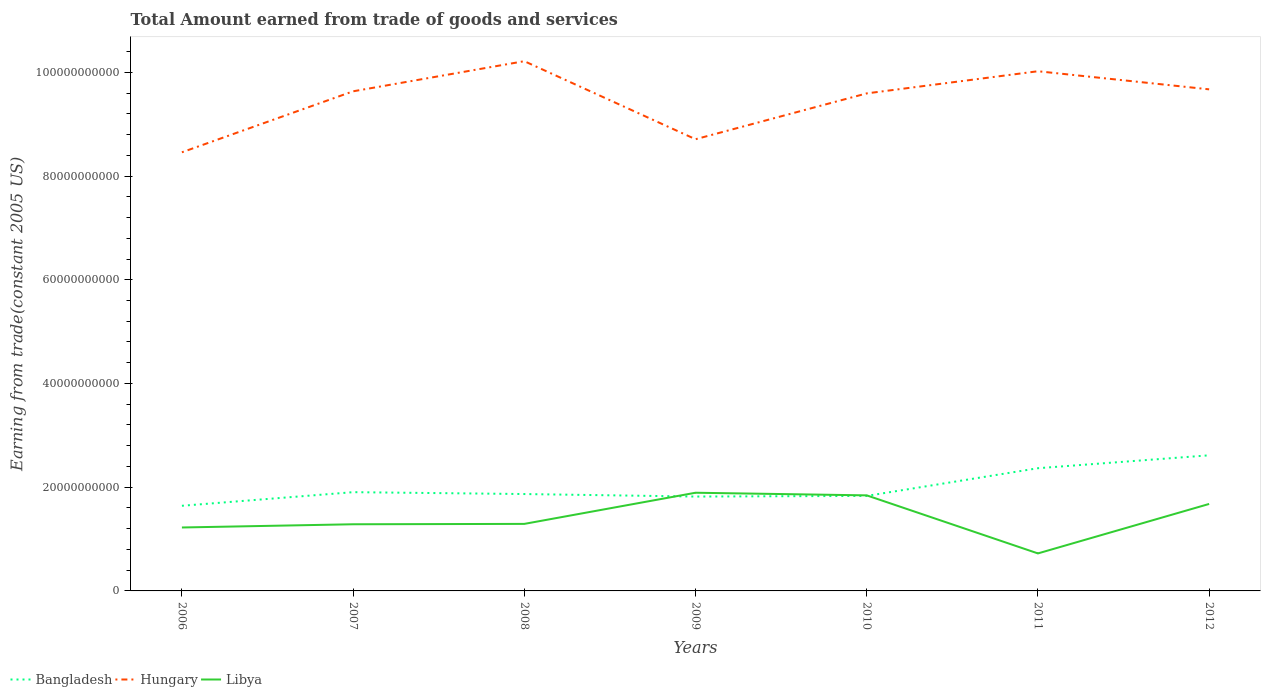Across all years, what is the maximum total amount earned by trading goods and services in Hungary?
Offer a terse response. 8.46e+1. In which year was the total amount earned by trading goods and services in Bangladesh maximum?
Ensure brevity in your answer.  2006. What is the total total amount earned by trading goods and services in Hungary in the graph?
Provide a short and direct response. -2.52e+09. What is the difference between the highest and the second highest total amount earned by trading goods and services in Hungary?
Provide a succinct answer. 1.76e+1. What is the difference between the highest and the lowest total amount earned by trading goods and services in Hungary?
Ensure brevity in your answer.  5. Is the total amount earned by trading goods and services in Hungary strictly greater than the total amount earned by trading goods and services in Libya over the years?
Your answer should be compact. No. How many years are there in the graph?
Provide a succinct answer. 7. Are the values on the major ticks of Y-axis written in scientific E-notation?
Ensure brevity in your answer.  No. Does the graph contain any zero values?
Offer a terse response. No. Where does the legend appear in the graph?
Your answer should be very brief. Bottom left. How many legend labels are there?
Your response must be concise. 3. How are the legend labels stacked?
Give a very brief answer. Horizontal. What is the title of the graph?
Your response must be concise. Total Amount earned from trade of goods and services. Does "Malawi" appear as one of the legend labels in the graph?
Offer a very short reply. No. What is the label or title of the Y-axis?
Offer a terse response. Earning from trade(constant 2005 US). What is the Earning from trade(constant 2005 US) in Bangladesh in 2006?
Give a very brief answer. 1.64e+1. What is the Earning from trade(constant 2005 US) of Hungary in 2006?
Your answer should be compact. 8.46e+1. What is the Earning from trade(constant 2005 US) in Libya in 2006?
Offer a terse response. 1.22e+1. What is the Earning from trade(constant 2005 US) in Bangladesh in 2007?
Offer a very short reply. 1.90e+1. What is the Earning from trade(constant 2005 US) in Hungary in 2007?
Ensure brevity in your answer.  9.63e+1. What is the Earning from trade(constant 2005 US) of Libya in 2007?
Give a very brief answer. 1.29e+1. What is the Earning from trade(constant 2005 US) in Bangladesh in 2008?
Offer a terse response. 1.87e+1. What is the Earning from trade(constant 2005 US) in Hungary in 2008?
Keep it short and to the point. 1.02e+11. What is the Earning from trade(constant 2005 US) of Libya in 2008?
Your answer should be compact. 1.29e+1. What is the Earning from trade(constant 2005 US) of Bangladesh in 2009?
Provide a succinct answer. 1.82e+1. What is the Earning from trade(constant 2005 US) in Hungary in 2009?
Your response must be concise. 8.71e+1. What is the Earning from trade(constant 2005 US) of Libya in 2009?
Give a very brief answer. 1.89e+1. What is the Earning from trade(constant 2005 US) in Bangladesh in 2010?
Offer a terse response. 1.83e+1. What is the Earning from trade(constant 2005 US) in Hungary in 2010?
Ensure brevity in your answer.  9.59e+1. What is the Earning from trade(constant 2005 US) in Libya in 2010?
Your answer should be very brief. 1.84e+1. What is the Earning from trade(constant 2005 US) in Bangladesh in 2011?
Keep it short and to the point. 2.37e+1. What is the Earning from trade(constant 2005 US) of Hungary in 2011?
Your response must be concise. 1.00e+11. What is the Earning from trade(constant 2005 US) of Libya in 2011?
Provide a succinct answer. 7.23e+09. What is the Earning from trade(constant 2005 US) in Bangladesh in 2012?
Ensure brevity in your answer.  2.61e+1. What is the Earning from trade(constant 2005 US) in Hungary in 2012?
Give a very brief answer. 9.67e+1. What is the Earning from trade(constant 2005 US) of Libya in 2012?
Offer a terse response. 1.68e+1. Across all years, what is the maximum Earning from trade(constant 2005 US) of Bangladesh?
Keep it short and to the point. 2.61e+1. Across all years, what is the maximum Earning from trade(constant 2005 US) of Hungary?
Offer a very short reply. 1.02e+11. Across all years, what is the maximum Earning from trade(constant 2005 US) in Libya?
Offer a terse response. 1.89e+1. Across all years, what is the minimum Earning from trade(constant 2005 US) in Bangladesh?
Make the answer very short. 1.64e+1. Across all years, what is the minimum Earning from trade(constant 2005 US) in Hungary?
Provide a short and direct response. 8.46e+1. Across all years, what is the minimum Earning from trade(constant 2005 US) of Libya?
Offer a very short reply. 7.23e+09. What is the total Earning from trade(constant 2005 US) of Bangladesh in the graph?
Ensure brevity in your answer.  1.40e+11. What is the total Earning from trade(constant 2005 US) of Hungary in the graph?
Make the answer very short. 6.63e+11. What is the total Earning from trade(constant 2005 US) of Libya in the graph?
Ensure brevity in your answer.  9.94e+1. What is the difference between the Earning from trade(constant 2005 US) in Bangladesh in 2006 and that in 2007?
Offer a terse response. -2.62e+09. What is the difference between the Earning from trade(constant 2005 US) in Hungary in 2006 and that in 2007?
Your answer should be compact. -1.18e+1. What is the difference between the Earning from trade(constant 2005 US) of Libya in 2006 and that in 2007?
Keep it short and to the point. -6.19e+08. What is the difference between the Earning from trade(constant 2005 US) in Bangladesh in 2006 and that in 2008?
Give a very brief answer. -2.26e+09. What is the difference between the Earning from trade(constant 2005 US) of Hungary in 2006 and that in 2008?
Make the answer very short. -1.76e+1. What is the difference between the Earning from trade(constant 2005 US) of Libya in 2006 and that in 2008?
Keep it short and to the point. -6.92e+08. What is the difference between the Earning from trade(constant 2005 US) of Bangladesh in 2006 and that in 2009?
Offer a very short reply. -1.78e+09. What is the difference between the Earning from trade(constant 2005 US) of Hungary in 2006 and that in 2009?
Provide a succinct answer. -2.52e+09. What is the difference between the Earning from trade(constant 2005 US) of Libya in 2006 and that in 2009?
Your answer should be very brief. -6.70e+09. What is the difference between the Earning from trade(constant 2005 US) in Bangladesh in 2006 and that in 2010?
Make the answer very short. -1.90e+09. What is the difference between the Earning from trade(constant 2005 US) of Hungary in 2006 and that in 2010?
Offer a very short reply. -1.14e+1. What is the difference between the Earning from trade(constant 2005 US) in Libya in 2006 and that in 2010?
Offer a terse response. -6.19e+09. What is the difference between the Earning from trade(constant 2005 US) in Bangladesh in 2006 and that in 2011?
Your answer should be very brief. -7.24e+09. What is the difference between the Earning from trade(constant 2005 US) of Hungary in 2006 and that in 2011?
Provide a short and direct response. -1.56e+1. What is the difference between the Earning from trade(constant 2005 US) in Libya in 2006 and that in 2011?
Your response must be concise. 5.00e+09. What is the difference between the Earning from trade(constant 2005 US) of Bangladesh in 2006 and that in 2012?
Ensure brevity in your answer.  -9.73e+09. What is the difference between the Earning from trade(constant 2005 US) in Hungary in 2006 and that in 2012?
Your answer should be compact. -1.21e+1. What is the difference between the Earning from trade(constant 2005 US) in Libya in 2006 and that in 2012?
Provide a succinct answer. -4.54e+09. What is the difference between the Earning from trade(constant 2005 US) in Bangladesh in 2007 and that in 2008?
Your answer should be very brief. 3.62e+08. What is the difference between the Earning from trade(constant 2005 US) in Hungary in 2007 and that in 2008?
Give a very brief answer. -5.81e+09. What is the difference between the Earning from trade(constant 2005 US) in Libya in 2007 and that in 2008?
Your response must be concise. -7.31e+07. What is the difference between the Earning from trade(constant 2005 US) in Bangladesh in 2007 and that in 2009?
Make the answer very short. 8.48e+08. What is the difference between the Earning from trade(constant 2005 US) of Hungary in 2007 and that in 2009?
Make the answer very short. 9.24e+09. What is the difference between the Earning from trade(constant 2005 US) in Libya in 2007 and that in 2009?
Offer a very short reply. -6.08e+09. What is the difference between the Earning from trade(constant 2005 US) of Bangladesh in 2007 and that in 2010?
Keep it short and to the point. 7.23e+08. What is the difference between the Earning from trade(constant 2005 US) in Hungary in 2007 and that in 2010?
Make the answer very short. 4.03e+08. What is the difference between the Earning from trade(constant 2005 US) of Libya in 2007 and that in 2010?
Offer a very short reply. -5.58e+09. What is the difference between the Earning from trade(constant 2005 US) in Bangladesh in 2007 and that in 2011?
Your answer should be compact. -4.62e+09. What is the difference between the Earning from trade(constant 2005 US) of Hungary in 2007 and that in 2011?
Give a very brief answer. -3.87e+09. What is the difference between the Earning from trade(constant 2005 US) of Libya in 2007 and that in 2011?
Make the answer very short. 5.62e+09. What is the difference between the Earning from trade(constant 2005 US) of Bangladesh in 2007 and that in 2012?
Give a very brief answer. -7.11e+09. What is the difference between the Earning from trade(constant 2005 US) of Hungary in 2007 and that in 2012?
Offer a very short reply. -3.78e+08. What is the difference between the Earning from trade(constant 2005 US) of Libya in 2007 and that in 2012?
Ensure brevity in your answer.  -3.92e+09. What is the difference between the Earning from trade(constant 2005 US) of Bangladesh in 2008 and that in 2009?
Offer a terse response. 4.86e+08. What is the difference between the Earning from trade(constant 2005 US) of Hungary in 2008 and that in 2009?
Make the answer very short. 1.50e+1. What is the difference between the Earning from trade(constant 2005 US) of Libya in 2008 and that in 2009?
Keep it short and to the point. -6.01e+09. What is the difference between the Earning from trade(constant 2005 US) of Bangladesh in 2008 and that in 2010?
Make the answer very short. 3.61e+08. What is the difference between the Earning from trade(constant 2005 US) in Hungary in 2008 and that in 2010?
Your answer should be compact. 6.21e+09. What is the difference between the Earning from trade(constant 2005 US) in Libya in 2008 and that in 2010?
Ensure brevity in your answer.  -5.50e+09. What is the difference between the Earning from trade(constant 2005 US) of Bangladesh in 2008 and that in 2011?
Offer a very short reply. -4.98e+09. What is the difference between the Earning from trade(constant 2005 US) in Hungary in 2008 and that in 2011?
Offer a terse response. 1.94e+09. What is the difference between the Earning from trade(constant 2005 US) of Libya in 2008 and that in 2011?
Keep it short and to the point. 5.69e+09. What is the difference between the Earning from trade(constant 2005 US) in Bangladesh in 2008 and that in 2012?
Ensure brevity in your answer.  -7.47e+09. What is the difference between the Earning from trade(constant 2005 US) of Hungary in 2008 and that in 2012?
Your answer should be very brief. 5.43e+09. What is the difference between the Earning from trade(constant 2005 US) of Libya in 2008 and that in 2012?
Offer a terse response. -3.85e+09. What is the difference between the Earning from trade(constant 2005 US) of Bangladesh in 2009 and that in 2010?
Your response must be concise. -1.25e+08. What is the difference between the Earning from trade(constant 2005 US) of Hungary in 2009 and that in 2010?
Offer a terse response. -8.84e+09. What is the difference between the Earning from trade(constant 2005 US) in Libya in 2009 and that in 2010?
Give a very brief answer. 5.07e+08. What is the difference between the Earning from trade(constant 2005 US) in Bangladesh in 2009 and that in 2011?
Keep it short and to the point. -5.47e+09. What is the difference between the Earning from trade(constant 2005 US) in Hungary in 2009 and that in 2011?
Ensure brevity in your answer.  -1.31e+1. What is the difference between the Earning from trade(constant 2005 US) of Libya in 2009 and that in 2011?
Your answer should be very brief. 1.17e+1. What is the difference between the Earning from trade(constant 2005 US) in Bangladesh in 2009 and that in 2012?
Your answer should be very brief. -7.95e+09. What is the difference between the Earning from trade(constant 2005 US) in Hungary in 2009 and that in 2012?
Provide a short and direct response. -9.62e+09. What is the difference between the Earning from trade(constant 2005 US) in Libya in 2009 and that in 2012?
Keep it short and to the point. 2.16e+09. What is the difference between the Earning from trade(constant 2005 US) in Bangladesh in 2010 and that in 2011?
Your answer should be very brief. -5.34e+09. What is the difference between the Earning from trade(constant 2005 US) of Hungary in 2010 and that in 2011?
Ensure brevity in your answer.  -4.27e+09. What is the difference between the Earning from trade(constant 2005 US) in Libya in 2010 and that in 2011?
Your answer should be very brief. 1.12e+1. What is the difference between the Earning from trade(constant 2005 US) in Bangladesh in 2010 and that in 2012?
Your answer should be very brief. -7.83e+09. What is the difference between the Earning from trade(constant 2005 US) of Hungary in 2010 and that in 2012?
Make the answer very short. -7.81e+08. What is the difference between the Earning from trade(constant 2005 US) of Libya in 2010 and that in 2012?
Give a very brief answer. 1.66e+09. What is the difference between the Earning from trade(constant 2005 US) in Bangladesh in 2011 and that in 2012?
Your response must be concise. -2.49e+09. What is the difference between the Earning from trade(constant 2005 US) of Hungary in 2011 and that in 2012?
Provide a short and direct response. 3.49e+09. What is the difference between the Earning from trade(constant 2005 US) of Libya in 2011 and that in 2012?
Your answer should be compact. -9.54e+09. What is the difference between the Earning from trade(constant 2005 US) of Bangladesh in 2006 and the Earning from trade(constant 2005 US) of Hungary in 2007?
Your response must be concise. -7.99e+1. What is the difference between the Earning from trade(constant 2005 US) of Bangladesh in 2006 and the Earning from trade(constant 2005 US) of Libya in 2007?
Your answer should be very brief. 3.57e+09. What is the difference between the Earning from trade(constant 2005 US) in Hungary in 2006 and the Earning from trade(constant 2005 US) in Libya in 2007?
Offer a terse response. 7.17e+1. What is the difference between the Earning from trade(constant 2005 US) in Bangladesh in 2006 and the Earning from trade(constant 2005 US) in Hungary in 2008?
Your response must be concise. -8.57e+1. What is the difference between the Earning from trade(constant 2005 US) in Bangladesh in 2006 and the Earning from trade(constant 2005 US) in Libya in 2008?
Offer a very short reply. 3.49e+09. What is the difference between the Earning from trade(constant 2005 US) of Hungary in 2006 and the Earning from trade(constant 2005 US) of Libya in 2008?
Your answer should be compact. 7.17e+1. What is the difference between the Earning from trade(constant 2005 US) in Bangladesh in 2006 and the Earning from trade(constant 2005 US) in Hungary in 2009?
Offer a terse response. -7.07e+1. What is the difference between the Earning from trade(constant 2005 US) of Bangladesh in 2006 and the Earning from trade(constant 2005 US) of Libya in 2009?
Make the answer very short. -2.52e+09. What is the difference between the Earning from trade(constant 2005 US) of Hungary in 2006 and the Earning from trade(constant 2005 US) of Libya in 2009?
Your answer should be compact. 6.56e+1. What is the difference between the Earning from trade(constant 2005 US) of Bangladesh in 2006 and the Earning from trade(constant 2005 US) of Hungary in 2010?
Provide a short and direct response. -7.95e+1. What is the difference between the Earning from trade(constant 2005 US) in Bangladesh in 2006 and the Earning from trade(constant 2005 US) in Libya in 2010?
Provide a short and direct response. -2.01e+09. What is the difference between the Earning from trade(constant 2005 US) in Hungary in 2006 and the Earning from trade(constant 2005 US) in Libya in 2010?
Provide a short and direct response. 6.62e+1. What is the difference between the Earning from trade(constant 2005 US) of Bangladesh in 2006 and the Earning from trade(constant 2005 US) of Hungary in 2011?
Give a very brief answer. -8.38e+1. What is the difference between the Earning from trade(constant 2005 US) in Bangladesh in 2006 and the Earning from trade(constant 2005 US) in Libya in 2011?
Your answer should be very brief. 9.18e+09. What is the difference between the Earning from trade(constant 2005 US) of Hungary in 2006 and the Earning from trade(constant 2005 US) of Libya in 2011?
Your response must be concise. 7.73e+1. What is the difference between the Earning from trade(constant 2005 US) in Bangladesh in 2006 and the Earning from trade(constant 2005 US) in Hungary in 2012?
Provide a short and direct response. -8.03e+1. What is the difference between the Earning from trade(constant 2005 US) of Bangladesh in 2006 and the Earning from trade(constant 2005 US) of Libya in 2012?
Provide a short and direct response. -3.53e+08. What is the difference between the Earning from trade(constant 2005 US) of Hungary in 2006 and the Earning from trade(constant 2005 US) of Libya in 2012?
Provide a short and direct response. 6.78e+1. What is the difference between the Earning from trade(constant 2005 US) of Bangladesh in 2007 and the Earning from trade(constant 2005 US) of Hungary in 2008?
Offer a terse response. -8.31e+1. What is the difference between the Earning from trade(constant 2005 US) in Bangladesh in 2007 and the Earning from trade(constant 2005 US) in Libya in 2008?
Provide a succinct answer. 6.12e+09. What is the difference between the Earning from trade(constant 2005 US) in Hungary in 2007 and the Earning from trade(constant 2005 US) in Libya in 2008?
Offer a very short reply. 8.34e+1. What is the difference between the Earning from trade(constant 2005 US) of Bangladesh in 2007 and the Earning from trade(constant 2005 US) of Hungary in 2009?
Provide a short and direct response. -6.81e+1. What is the difference between the Earning from trade(constant 2005 US) of Bangladesh in 2007 and the Earning from trade(constant 2005 US) of Libya in 2009?
Ensure brevity in your answer.  1.09e+08. What is the difference between the Earning from trade(constant 2005 US) of Hungary in 2007 and the Earning from trade(constant 2005 US) of Libya in 2009?
Your answer should be compact. 7.74e+1. What is the difference between the Earning from trade(constant 2005 US) in Bangladesh in 2007 and the Earning from trade(constant 2005 US) in Hungary in 2010?
Offer a very short reply. -7.69e+1. What is the difference between the Earning from trade(constant 2005 US) of Bangladesh in 2007 and the Earning from trade(constant 2005 US) of Libya in 2010?
Give a very brief answer. 6.16e+08. What is the difference between the Earning from trade(constant 2005 US) of Hungary in 2007 and the Earning from trade(constant 2005 US) of Libya in 2010?
Provide a short and direct response. 7.79e+1. What is the difference between the Earning from trade(constant 2005 US) of Bangladesh in 2007 and the Earning from trade(constant 2005 US) of Hungary in 2011?
Offer a terse response. -8.12e+1. What is the difference between the Earning from trade(constant 2005 US) of Bangladesh in 2007 and the Earning from trade(constant 2005 US) of Libya in 2011?
Give a very brief answer. 1.18e+1. What is the difference between the Earning from trade(constant 2005 US) of Hungary in 2007 and the Earning from trade(constant 2005 US) of Libya in 2011?
Your response must be concise. 8.91e+1. What is the difference between the Earning from trade(constant 2005 US) in Bangladesh in 2007 and the Earning from trade(constant 2005 US) in Hungary in 2012?
Offer a terse response. -7.77e+1. What is the difference between the Earning from trade(constant 2005 US) in Bangladesh in 2007 and the Earning from trade(constant 2005 US) in Libya in 2012?
Ensure brevity in your answer.  2.27e+09. What is the difference between the Earning from trade(constant 2005 US) of Hungary in 2007 and the Earning from trade(constant 2005 US) of Libya in 2012?
Give a very brief answer. 7.96e+1. What is the difference between the Earning from trade(constant 2005 US) in Bangladesh in 2008 and the Earning from trade(constant 2005 US) in Hungary in 2009?
Offer a terse response. -6.84e+1. What is the difference between the Earning from trade(constant 2005 US) of Bangladesh in 2008 and the Earning from trade(constant 2005 US) of Libya in 2009?
Give a very brief answer. -2.53e+08. What is the difference between the Earning from trade(constant 2005 US) in Hungary in 2008 and the Earning from trade(constant 2005 US) in Libya in 2009?
Make the answer very short. 8.32e+1. What is the difference between the Earning from trade(constant 2005 US) in Bangladesh in 2008 and the Earning from trade(constant 2005 US) in Hungary in 2010?
Offer a very short reply. -7.73e+1. What is the difference between the Earning from trade(constant 2005 US) in Bangladesh in 2008 and the Earning from trade(constant 2005 US) in Libya in 2010?
Offer a terse response. 2.54e+08. What is the difference between the Earning from trade(constant 2005 US) in Hungary in 2008 and the Earning from trade(constant 2005 US) in Libya in 2010?
Offer a terse response. 8.37e+1. What is the difference between the Earning from trade(constant 2005 US) in Bangladesh in 2008 and the Earning from trade(constant 2005 US) in Hungary in 2011?
Keep it short and to the point. -8.15e+1. What is the difference between the Earning from trade(constant 2005 US) of Bangladesh in 2008 and the Earning from trade(constant 2005 US) of Libya in 2011?
Your answer should be compact. 1.14e+1. What is the difference between the Earning from trade(constant 2005 US) in Hungary in 2008 and the Earning from trade(constant 2005 US) in Libya in 2011?
Provide a succinct answer. 9.49e+1. What is the difference between the Earning from trade(constant 2005 US) in Bangladesh in 2008 and the Earning from trade(constant 2005 US) in Hungary in 2012?
Provide a short and direct response. -7.80e+1. What is the difference between the Earning from trade(constant 2005 US) of Bangladesh in 2008 and the Earning from trade(constant 2005 US) of Libya in 2012?
Ensure brevity in your answer.  1.91e+09. What is the difference between the Earning from trade(constant 2005 US) in Hungary in 2008 and the Earning from trade(constant 2005 US) in Libya in 2012?
Ensure brevity in your answer.  8.54e+1. What is the difference between the Earning from trade(constant 2005 US) of Bangladesh in 2009 and the Earning from trade(constant 2005 US) of Hungary in 2010?
Offer a terse response. -7.77e+1. What is the difference between the Earning from trade(constant 2005 US) of Bangladesh in 2009 and the Earning from trade(constant 2005 US) of Libya in 2010?
Keep it short and to the point. -2.32e+08. What is the difference between the Earning from trade(constant 2005 US) in Hungary in 2009 and the Earning from trade(constant 2005 US) in Libya in 2010?
Ensure brevity in your answer.  6.87e+1. What is the difference between the Earning from trade(constant 2005 US) in Bangladesh in 2009 and the Earning from trade(constant 2005 US) in Hungary in 2011?
Your answer should be compact. -8.20e+1. What is the difference between the Earning from trade(constant 2005 US) of Bangladesh in 2009 and the Earning from trade(constant 2005 US) of Libya in 2011?
Offer a terse response. 1.10e+1. What is the difference between the Earning from trade(constant 2005 US) in Hungary in 2009 and the Earning from trade(constant 2005 US) in Libya in 2011?
Provide a short and direct response. 7.99e+1. What is the difference between the Earning from trade(constant 2005 US) in Bangladesh in 2009 and the Earning from trade(constant 2005 US) in Hungary in 2012?
Provide a succinct answer. -7.85e+1. What is the difference between the Earning from trade(constant 2005 US) in Bangladesh in 2009 and the Earning from trade(constant 2005 US) in Libya in 2012?
Offer a terse response. 1.42e+09. What is the difference between the Earning from trade(constant 2005 US) in Hungary in 2009 and the Earning from trade(constant 2005 US) in Libya in 2012?
Provide a succinct answer. 7.03e+1. What is the difference between the Earning from trade(constant 2005 US) in Bangladesh in 2010 and the Earning from trade(constant 2005 US) in Hungary in 2011?
Give a very brief answer. -8.19e+1. What is the difference between the Earning from trade(constant 2005 US) in Bangladesh in 2010 and the Earning from trade(constant 2005 US) in Libya in 2011?
Your answer should be very brief. 1.11e+1. What is the difference between the Earning from trade(constant 2005 US) of Hungary in 2010 and the Earning from trade(constant 2005 US) of Libya in 2011?
Provide a succinct answer. 8.87e+1. What is the difference between the Earning from trade(constant 2005 US) in Bangladesh in 2010 and the Earning from trade(constant 2005 US) in Hungary in 2012?
Provide a short and direct response. -7.84e+1. What is the difference between the Earning from trade(constant 2005 US) in Bangladesh in 2010 and the Earning from trade(constant 2005 US) in Libya in 2012?
Your response must be concise. 1.55e+09. What is the difference between the Earning from trade(constant 2005 US) in Hungary in 2010 and the Earning from trade(constant 2005 US) in Libya in 2012?
Ensure brevity in your answer.  7.92e+1. What is the difference between the Earning from trade(constant 2005 US) in Bangladesh in 2011 and the Earning from trade(constant 2005 US) in Hungary in 2012?
Your answer should be compact. -7.31e+1. What is the difference between the Earning from trade(constant 2005 US) of Bangladesh in 2011 and the Earning from trade(constant 2005 US) of Libya in 2012?
Provide a short and direct response. 6.89e+09. What is the difference between the Earning from trade(constant 2005 US) of Hungary in 2011 and the Earning from trade(constant 2005 US) of Libya in 2012?
Offer a very short reply. 8.34e+1. What is the average Earning from trade(constant 2005 US) in Bangladesh per year?
Provide a short and direct response. 2.01e+1. What is the average Earning from trade(constant 2005 US) of Hungary per year?
Your response must be concise. 9.47e+1. What is the average Earning from trade(constant 2005 US) of Libya per year?
Ensure brevity in your answer.  1.42e+1. In the year 2006, what is the difference between the Earning from trade(constant 2005 US) of Bangladesh and Earning from trade(constant 2005 US) of Hungary?
Ensure brevity in your answer.  -6.82e+1. In the year 2006, what is the difference between the Earning from trade(constant 2005 US) in Bangladesh and Earning from trade(constant 2005 US) in Libya?
Ensure brevity in your answer.  4.19e+09. In the year 2006, what is the difference between the Earning from trade(constant 2005 US) in Hungary and Earning from trade(constant 2005 US) in Libya?
Offer a very short reply. 7.23e+1. In the year 2007, what is the difference between the Earning from trade(constant 2005 US) in Bangladesh and Earning from trade(constant 2005 US) in Hungary?
Give a very brief answer. -7.73e+1. In the year 2007, what is the difference between the Earning from trade(constant 2005 US) of Bangladesh and Earning from trade(constant 2005 US) of Libya?
Make the answer very short. 6.19e+09. In the year 2007, what is the difference between the Earning from trade(constant 2005 US) of Hungary and Earning from trade(constant 2005 US) of Libya?
Your answer should be compact. 8.35e+1. In the year 2008, what is the difference between the Earning from trade(constant 2005 US) of Bangladesh and Earning from trade(constant 2005 US) of Hungary?
Offer a very short reply. -8.35e+1. In the year 2008, what is the difference between the Earning from trade(constant 2005 US) of Bangladesh and Earning from trade(constant 2005 US) of Libya?
Your answer should be compact. 5.76e+09. In the year 2008, what is the difference between the Earning from trade(constant 2005 US) in Hungary and Earning from trade(constant 2005 US) in Libya?
Provide a succinct answer. 8.92e+1. In the year 2009, what is the difference between the Earning from trade(constant 2005 US) of Bangladesh and Earning from trade(constant 2005 US) of Hungary?
Offer a very short reply. -6.89e+1. In the year 2009, what is the difference between the Earning from trade(constant 2005 US) in Bangladesh and Earning from trade(constant 2005 US) in Libya?
Provide a succinct answer. -7.38e+08. In the year 2009, what is the difference between the Earning from trade(constant 2005 US) of Hungary and Earning from trade(constant 2005 US) of Libya?
Make the answer very short. 6.82e+1. In the year 2010, what is the difference between the Earning from trade(constant 2005 US) of Bangladesh and Earning from trade(constant 2005 US) of Hungary?
Your answer should be compact. -7.76e+1. In the year 2010, what is the difference between the Earning from trade(constant 2005 US) in Bangladesh and Earning from trade(constant 2005 US) in Libya?
Keep it short and to the point. -1.07e+08. In the year 2010, what is the difference between the Earning from trade(constant 2005 US) of Hungary and Earning from trade(constant 2005 US) of Libya?
Offer a very short reply. 7.75e+1. In the year 2011, what is the difference between the Earning from trade(constant 2005 US) of Bangladesh and Earning from trade(constant 2005 US) of Hungary?
Ensure brevity in your answer.  -7.65e+1. In the year 2011, what is the difference between the Earning from trade(constant 2005 US) of Bangladesh and Earning from trade(constant 2005 US) of Libya?
Keep it short and to the point. 1.64e+1. In the year 2011, what is the difference between the Earning from trade(constant 2005 US) of Hungary and Earning from trade(constant 2005 US) of Libya?
Provide a succinct answer. 9.30e+1. In the year 2012, what is the difference between the Earning from trade(constant 2005 US) in Bangladesh and Earning from trade(constant 2005 US) in Hungary?
Your response must be concise. -7.06e+1. In the year 2012, what is the difference between the Earning from trade(constant 2005 US) of Bangladesh and Earning from trade(constant 2005 US) of Libya?
Make the answer very short. 9.38e+09. In the year 2012, what is the difference between the Earning from trade(constant 2005 US) in Hungary and Earning from trade(constant 2005 US) in Libya?
Keep it short and to the point. 7.99e+1. What is the ratio of the Earning from trade(constant 2005 US) of Bangladesh in 2006 to that in 2007?
Offer a very short reply. 0.86. What is the ratio of the Earning from trade(constant 2005 US) of Hungary in 2006 to that in 2007?
Your answer should be very brief. 0.88. What is the ratio of the Earning from trade(constant 2005 US) in Libya in 2006 to that in 2007?
Offer a very short reply. 0.95. What is the ratio of the Earning from trade(constant 2005 US) of Bangladesh in 2006 to that in 2008?
Offer a terse response. 0.88. What is the ratio of the Earning from trade(constant 2005 US) of Hungary in 2006 to that in 2008?
Provide a succinct answer. 0.83. What is the ratio of the Earning from trade(constant 2005 US) in Libya in 2006 to that in 2008?
Ensure brevity in your answer.  0.95. What is the ratio of the Earning from trade(constant 2005 US) of Bangladesh in 2006 to that in 2009?
Ensure brevity in your answer.  0.9. What is the ratio of the Earning from trade(constant 2005 US) in Hungary in 2006 to that in 2009?
Offer a very short reply. 0.97. What is the ratio of the Earning from trade(constant 2005 US) in Libya in 2006 to that in 2009?
Give a very brief answer. 0.65. What is the ratio of the Earning from trade(constant 2005 US) in Bangladesh in 2006 to that in 2010?
Provide a succinct answer. 0.9. What is the ratio of the Earning from trade(constant 2005 US) in Hungary in 2006 to that in 2010?
Offer a very short reply. 0.88. What is the ratio of the Earning from trade(constant 2005 US) of Libya in 2006 to that in 2010?
Your answer should be compact. 0.66. What is the ratio of the Earning from trade(constant 2005 US) of Bangladesh in 2006 to that in 2011?
Offer a very short reply. 0.69. What is the ratio of the Earning from trade(constant 2005 US) in Hungary in 2006 to that in 2011?
Offer a very short reply. 0.84. What is the ratio of the Earning from trade(constant 2005 US) of Libya in 2006 to that in 2011?
Offer a very short reply. 1.69. What is the ratio of the Earning from trade(constant 2005 US) in Bangladesh in 2006 to that in 2012?
Provide a short and direct response. 0.63. What is the ratio of the Earning from trade(constant 2005 US) in Hungary in 2006 to that in 2012?
Provide a short and direct response. 0.87. What is the ratio of the Earning from trade(constant 2005 US) in Libya in 2006 to that in 2012?
Keep it short and to the point. 0.73. What is the ratio of the Earning from trade(constant 2005 US) of Bangladesh in 2007 to that in 2008?
Your answer should be very brief. 1.02. What is the ratio of the Earning from trade(constant 2005 US) of Hungary in 2007 to that in 2008?
Your answer should be very brief. 0.94. What is the ratio of the Earning from trade(constant 2005 US) of Bangladesh in 2007 to that in 2009?
Offer a very short reply. 1.05. What is the ratio of the Earning from trade(constant 2005 US) of Hungary in 2007 to that in 2009?
Provide a succinct answer. 1.11. What is the ratio of the Earning from trade(constant 2005 US) in Libya in 2007 to that in 2009?
Your answer should be very brief. 0.68. What is the ratio of the Earning from trade(constant 2005 US) of Bangladesh in 2007 to that in 2010?
Offer a terse response. 1.04. What is the ratio of the Earning from trade(constant 2005 US) of Libya in 2007 to that in 2010?
Offer a very short reply. 0.7. What is the ratio of the Earning from trade(constant 2005 US) in Bangladesh in 2007 to that in 2011?
Offer a terse response. 0.8. What is the ratio of the Earning from trade(constant 2005 US) in Hungary in 2007 to that in 2011?
Make the answer very short. 0.96. What is the ratio of the Earning from trade(constant 2005 US) of Libya in 2007 to that in 2011?
Your response must be concise. 1.78. What is the ratio of the Earning from trade(constant 2005 US) in Bangladesh in 2007 to that in 2012?
Provide a succinct answer. 0.73. What is the ratio of the Earning from trade(constant 2005 US) in Libya in 2007 to that in 2012?
Offer a very short reply. 0.77. What is the ratio of the Earning from trade(constant 2005 US) in Bangladesh in 2008 to that in 2009?
Make the answer very short. 1.03. What is the ratio of the Earning from trade(constant 2005 US) in Hungary in 2008 to that in 2009?
Keep it short and to the point. 1.17. What is the ratio of the Earning from trade(constant 2005 US) in Libya in 2008 to that in 2009?
Keep it short and to the point. 0.68. What is the ratio of the Earning from trade(constant 2005 US) in Bangladesh in 2008 to that in 2010?
Ensure brevity in your answer.  1.02. What is the ratio of the Earning from trade(constant 2005 US) of Hungary in 2008 to that in 2010?
Your answer should be very brief. 1.06. What is the ratio of the Earning from trade(constant 2005 US) of Libya in 2008 to that in 2010?
Offer a very short reply. 0.7. What is the ratio of the Earning from trade(constant 2005 US) of Bangladesh in 2008 to that in 2011?
Offer a terse response. 0.79. What is the ratio of the Earning from trade(constant 2005 US) in Hungary in 2008 to that in 2011?
Ensure brevity in your answer.  1.02. What is the ratio of the Earning from trade(constant 2005 US) of Libya in 2008 to that in 2011?
Provide a succinct answer. 1.79. What is the ratio of the Earning from trade(constant 2005 US) in Bangladesh in 2008 to that in 2012?
Make the answer very short. 0.71. What is the ratio of the Earning from trade(constant 2005 US) in Hungary in 2008 to that in 2012?
Offer a terse response. 1.06. What is the ratio of the Earning from trade(constant 2005 US) of Libya in 2008 to that in 2012?
Provide a succinct answer. 0.77. What is the ratio of the Earning from trade(constant 2005 US) of Bangladesh in 2009 to that in 2010?
Provide a succinct answer. 0.99. What is the ratio of the Earning from trade(constant 2005 US) of Hungary in 2009 to that in 2010?
Make the answer very short. 0.91. What is the ratio of the Earning from trade(constant 2005 US) in Libya in 2009 to that in 2010?
Offer a terse response. 1.03. What is the ratio of the Earning from trade(constant 2005 US) in Bangladesh in 2009 to that in 2011?
Your answer should be compact. 0.77. What is the ratio of the Earning from trade(constant 2005 US) in Hungary in 2009 to that in 2011?
Keep it short and to the point. 0.87. What is the ratio of the Earning from trade(constant 2005 US) in Libya in 2009 to that in 2011?
Keep it short and to the point. 2.62. What is the ratio of the Earning from trade(constant 2005 US) of Bangladesh in 2009 to that in 2012?
Make the answer very short. 0.7. What is the ratio of the Earning from trade(constant 2005 US) of Hungary in 2009 to that in 2012?
Make the answer very short. 0.9. What is the ratio of the Earning from trade(constant 2005 US) of Libya in 2009 to that in 2012?
Your answer should be very brief. 1.13. What is the ratio of the Earning from trade(constant 2005 US) of Bangladesh in 2010 to that in 2011?
Your answer should be compact. 0.77. What is the ratio of the Earning from trade(constant 2005 US) of Hungary in 2010 to that in 2011?
Provide a short and direct response. 0.96. What is the ratio of the Earning from trade(constant 2005 US) of Libya in 2010 to that in 2011?
Offer a terse response. 2.55. What is the ratio of the Earning from trade(constant 2005 US) in Bangladesh in 2010 to that in 2012?
Provide a short and direct response. 0.7. What is the ratio of the Earning from trade(constant 2005 US) of Libya in 2010 to that in 2012?
Ensure brevity in your answer.  1.1. What is the ratio of the Earning from trade(constant 2005 US) of Bangladesh in 2011 to that in 2012?
Offer a very short reply. 0.9. What is the ratio of the Earning from trade(constant 2005 US) of Hungary in 2011 to that in 2012?
Your response must be concise. 1.04. What is the ratio of the Earning from trade(constant 2005 US) in Libya in 2011 to that in 2012?
Keep it short and to the point. 0.43. What is the difference between the highest and the second highest Earning from trade(constant 2005 US) of Bangladesh?
Your answer should be very brief. 2.49e+09. What is the difference between the highest and the second highest Earning from trade(constant 2005 US) in Hungary?
Provide a short and direct response. 1.94e+09. What is the difference between the highest and the second highest Earning from trade(constant 2005 US) in Libya?
Keep it short and to the point. 5.07e+08. What is the difference between the highest and the lowest Earning from trade(constant 2005 US) of Bangladesh?
Offer a very short reply. 9.73e+09. What is the difference between the highest and the lowest Earning from trade(constant 2005 US) of Hungary?
Provide a succinct answer. 1.76e+1. What is the difference between the highest and the lowest Earning from trade(constant 2005 US) in Libya?
Your answer should be compact. 1.17e+1. 